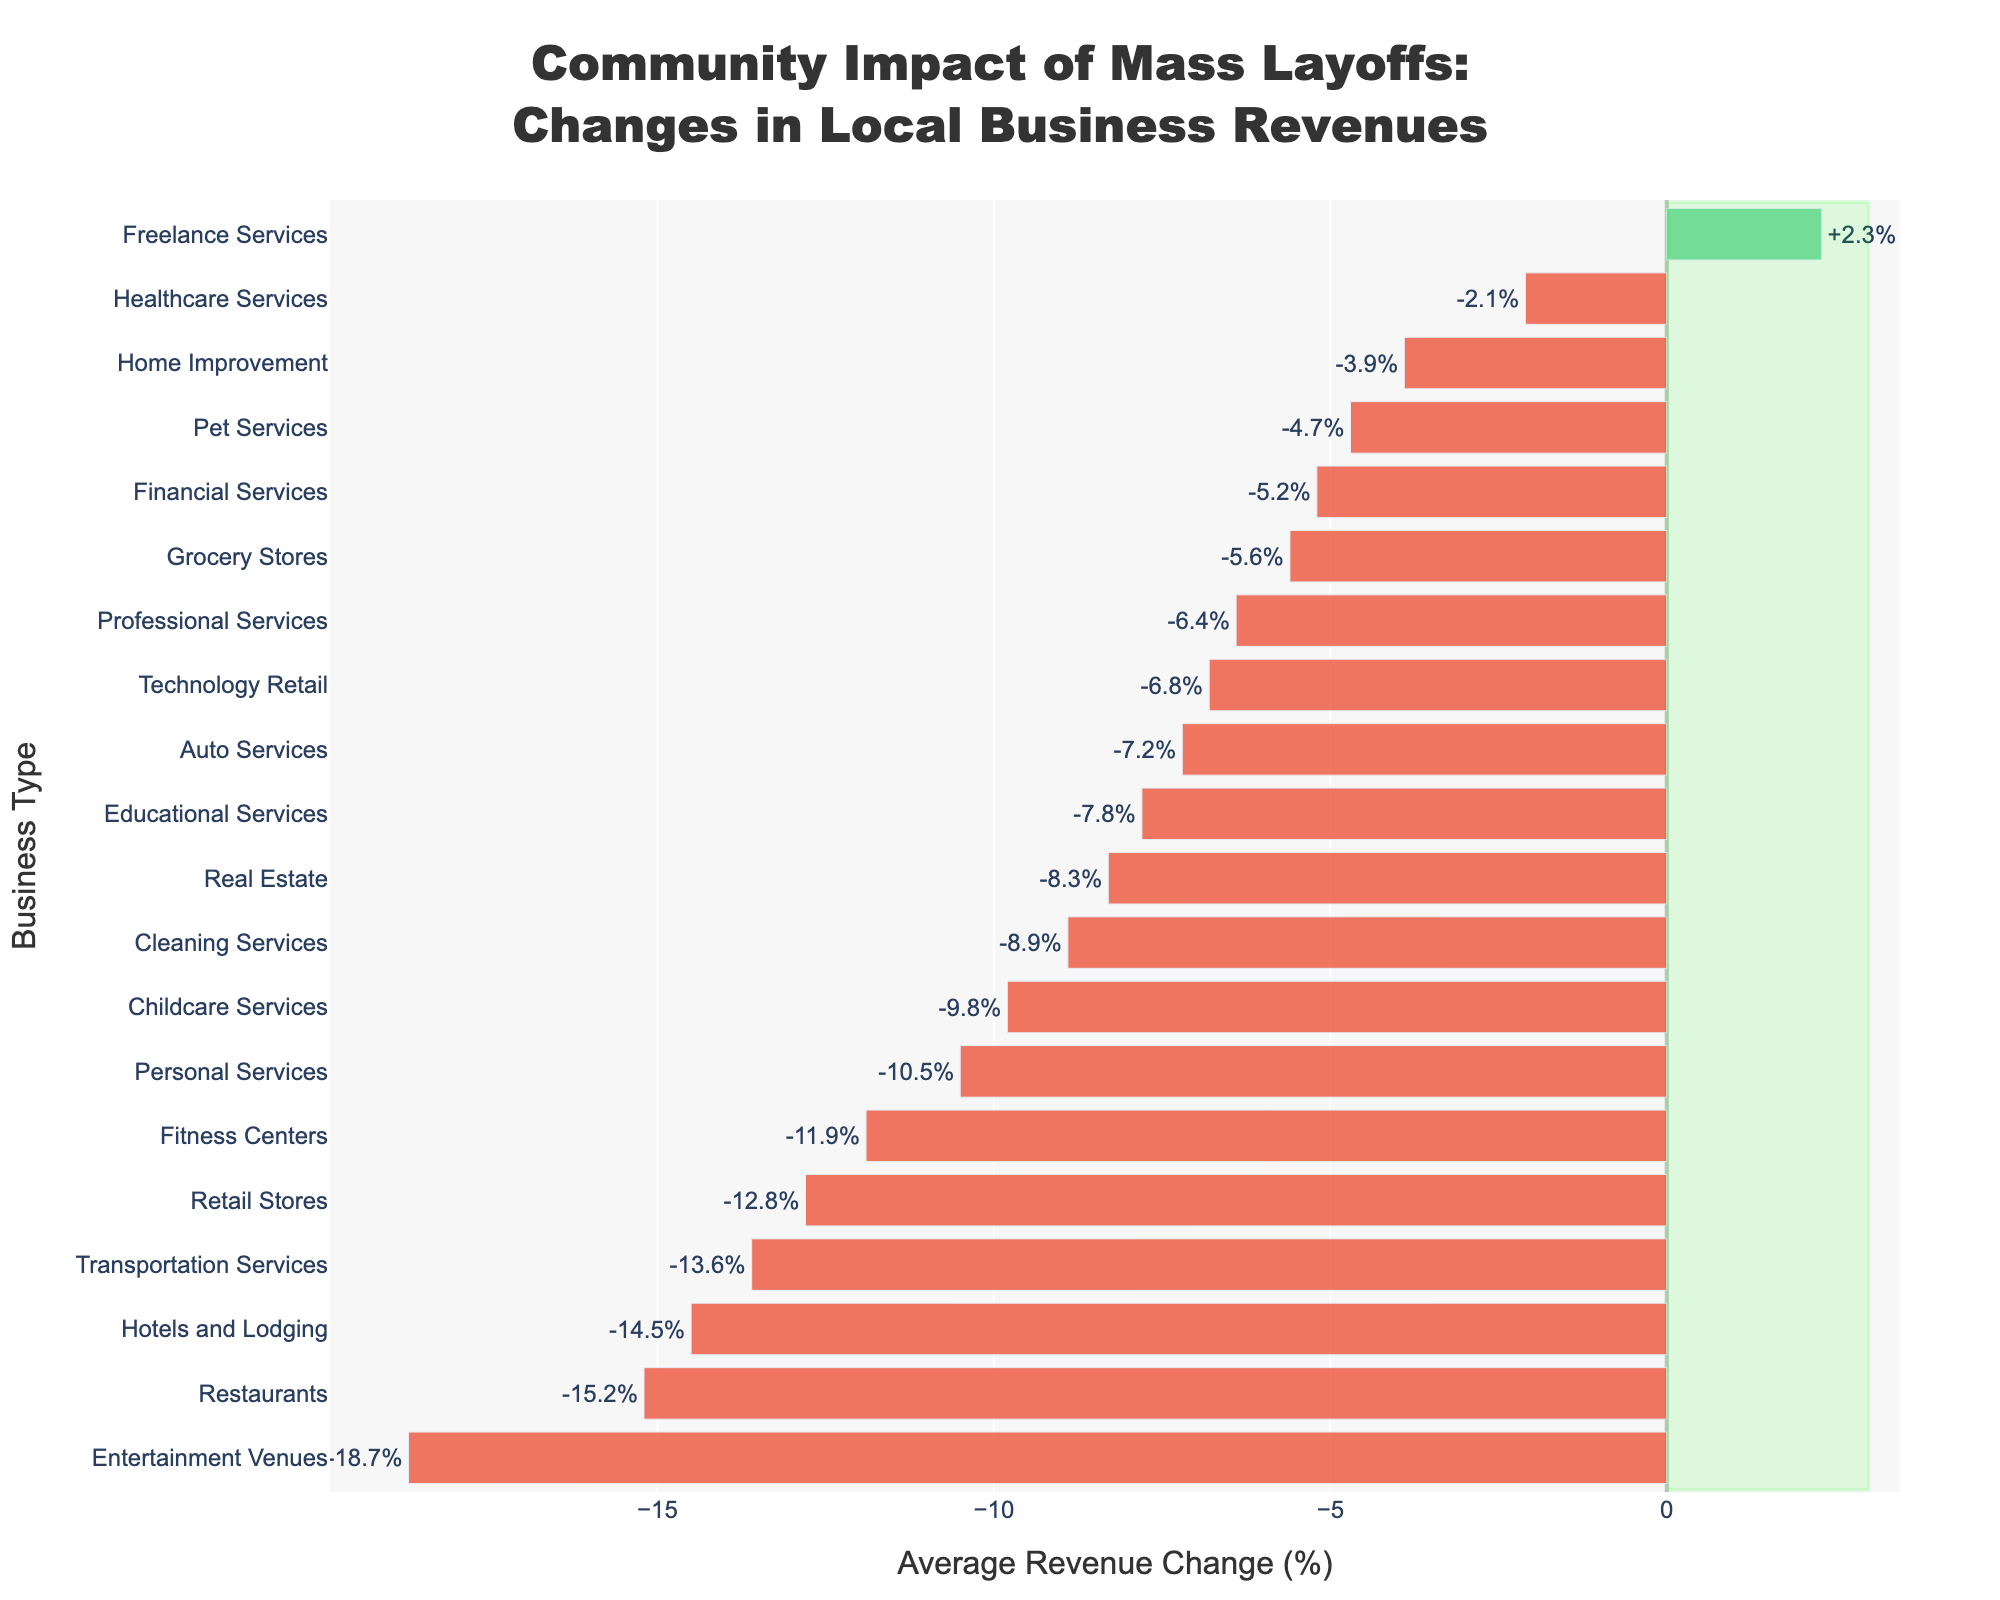Which business type experienced the largest drop in average revenue? The bar showing the largest negative percentage is identified. The longest red bar corresponds to Entertainment Venues with -18.7%.
Answer: Entertainment Venues Which business type is the only one to see a positive change in average revenue? Observing the color and signs of the percentages, only Freelance Services has a green bar with a positive change of +2.3%.
Answer: Freelance Services How does the average revenue change of Grocery Stores compare to that of Financial Services? Both Grocery Stores and Financial Services have small revenue drops. Grocery Stores have -5.6% while Financial Services have -5.2%, indicating that Grocery Stores dropped slightly more.
Answer: Grocery Stores dropped more What is the combined average revenue change for Restaurants and Hotels and Lodging? Summing the average revenue changes for Restaurants (-15.2%) and Hotels and Lodging (-14.5%) gives the combined effect: -15.2 + (-14.5) = -29.7.
Answer: -29.7% Which service experienced a greater revenue loss, Auto Services or Cleaning Services? Looking at the bar lengths and percentages, Auto Services have -7.2% while Cleaning Services have -8.9%, indicating Cleaning Services experienced a greater revenue loss.
Answer: Cleaning Services What's the average revenue change for the three services with the smallest losses? Identifying and averaging the three smallest negative changes: Healthcare Services (-2.1%), Home Improvement (-3.9%), and Pet Services (-4.7%): (-(2.1 + 3.9 + 4.7)) / 3 = -3.57%.
Answer: -3.6% Which sector experienced a bigger drop in revenue, Entertainment Venues or Transportation Services? Comparing the percentages, Entertainment Venues have -18.7% and Transportation Services have -13.6%. Entertainment Venues experienced a bigger drop.
Answer: Entertainment Venues 